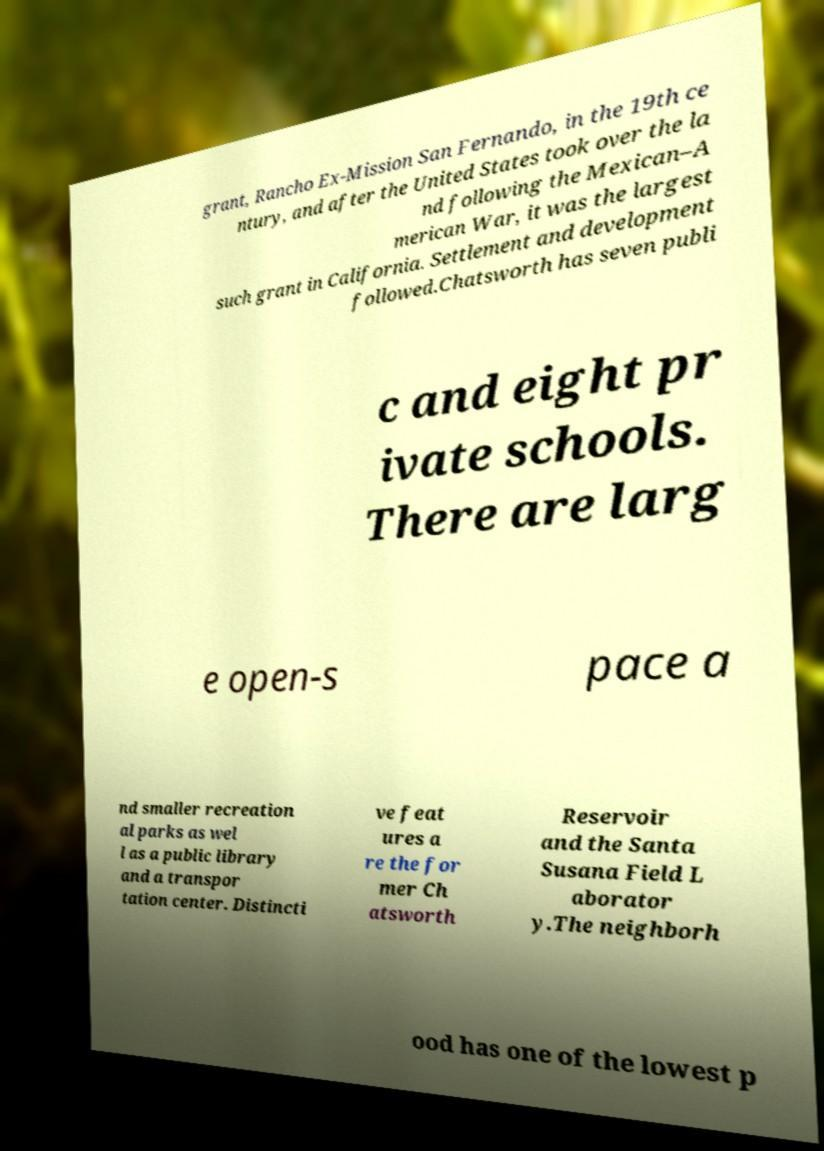There's text embedded in this image that I need extracted. Can you transcribe it verbatim? grant, Rancho Ex-Mission San Fernando, in the 19th ce ntury, and after the United States took over the la nd following the Mexican–A merican War, it was the largest such grant in California. Settlement and development followed.Chatsworth has seven publi c and eight pr ivate schools. There are larg e open-s pace a nd smaller recreation al parks as wel l as a public library and a transpor tation center. Distincti ve feat ures a re the for mer Ch atsworth Reservoir and the Santa Susana Field L aborator y.The neighborh ood has one of the lowest p 